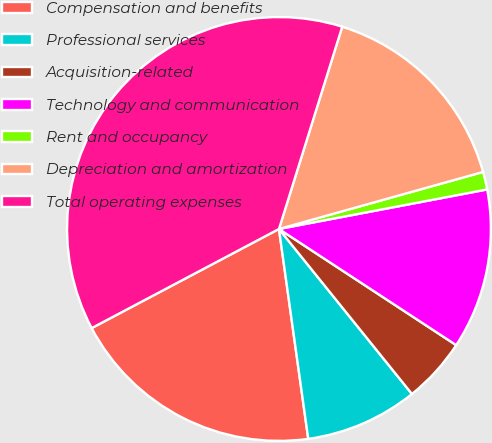<chart> <loc_0><loc_0><loc_500><loc_500><pie_chart><fcel>Compensation and benefits<fcel>Professional services<fcel>Acquisition-related<fcel>Technology and communication<fcel>Rent and occupancy<fcel>Depreciation and amortization<fcel>Total operating expenses<nl><fcel>19.46%<fcel>8.59%<fcel>4.97%<fcel>12.22%<fcel>1.35%<fcel>15.84%<fcel>37.57%<nl></chart> 